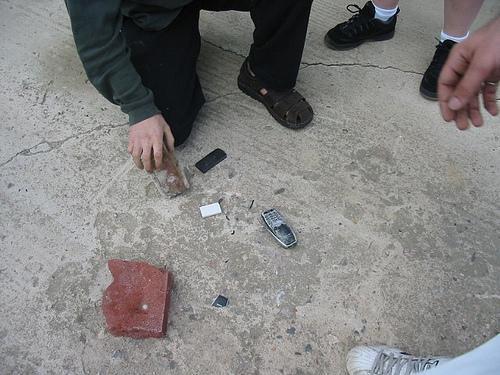How many people are visible?
Give a very brief answer. 3. 